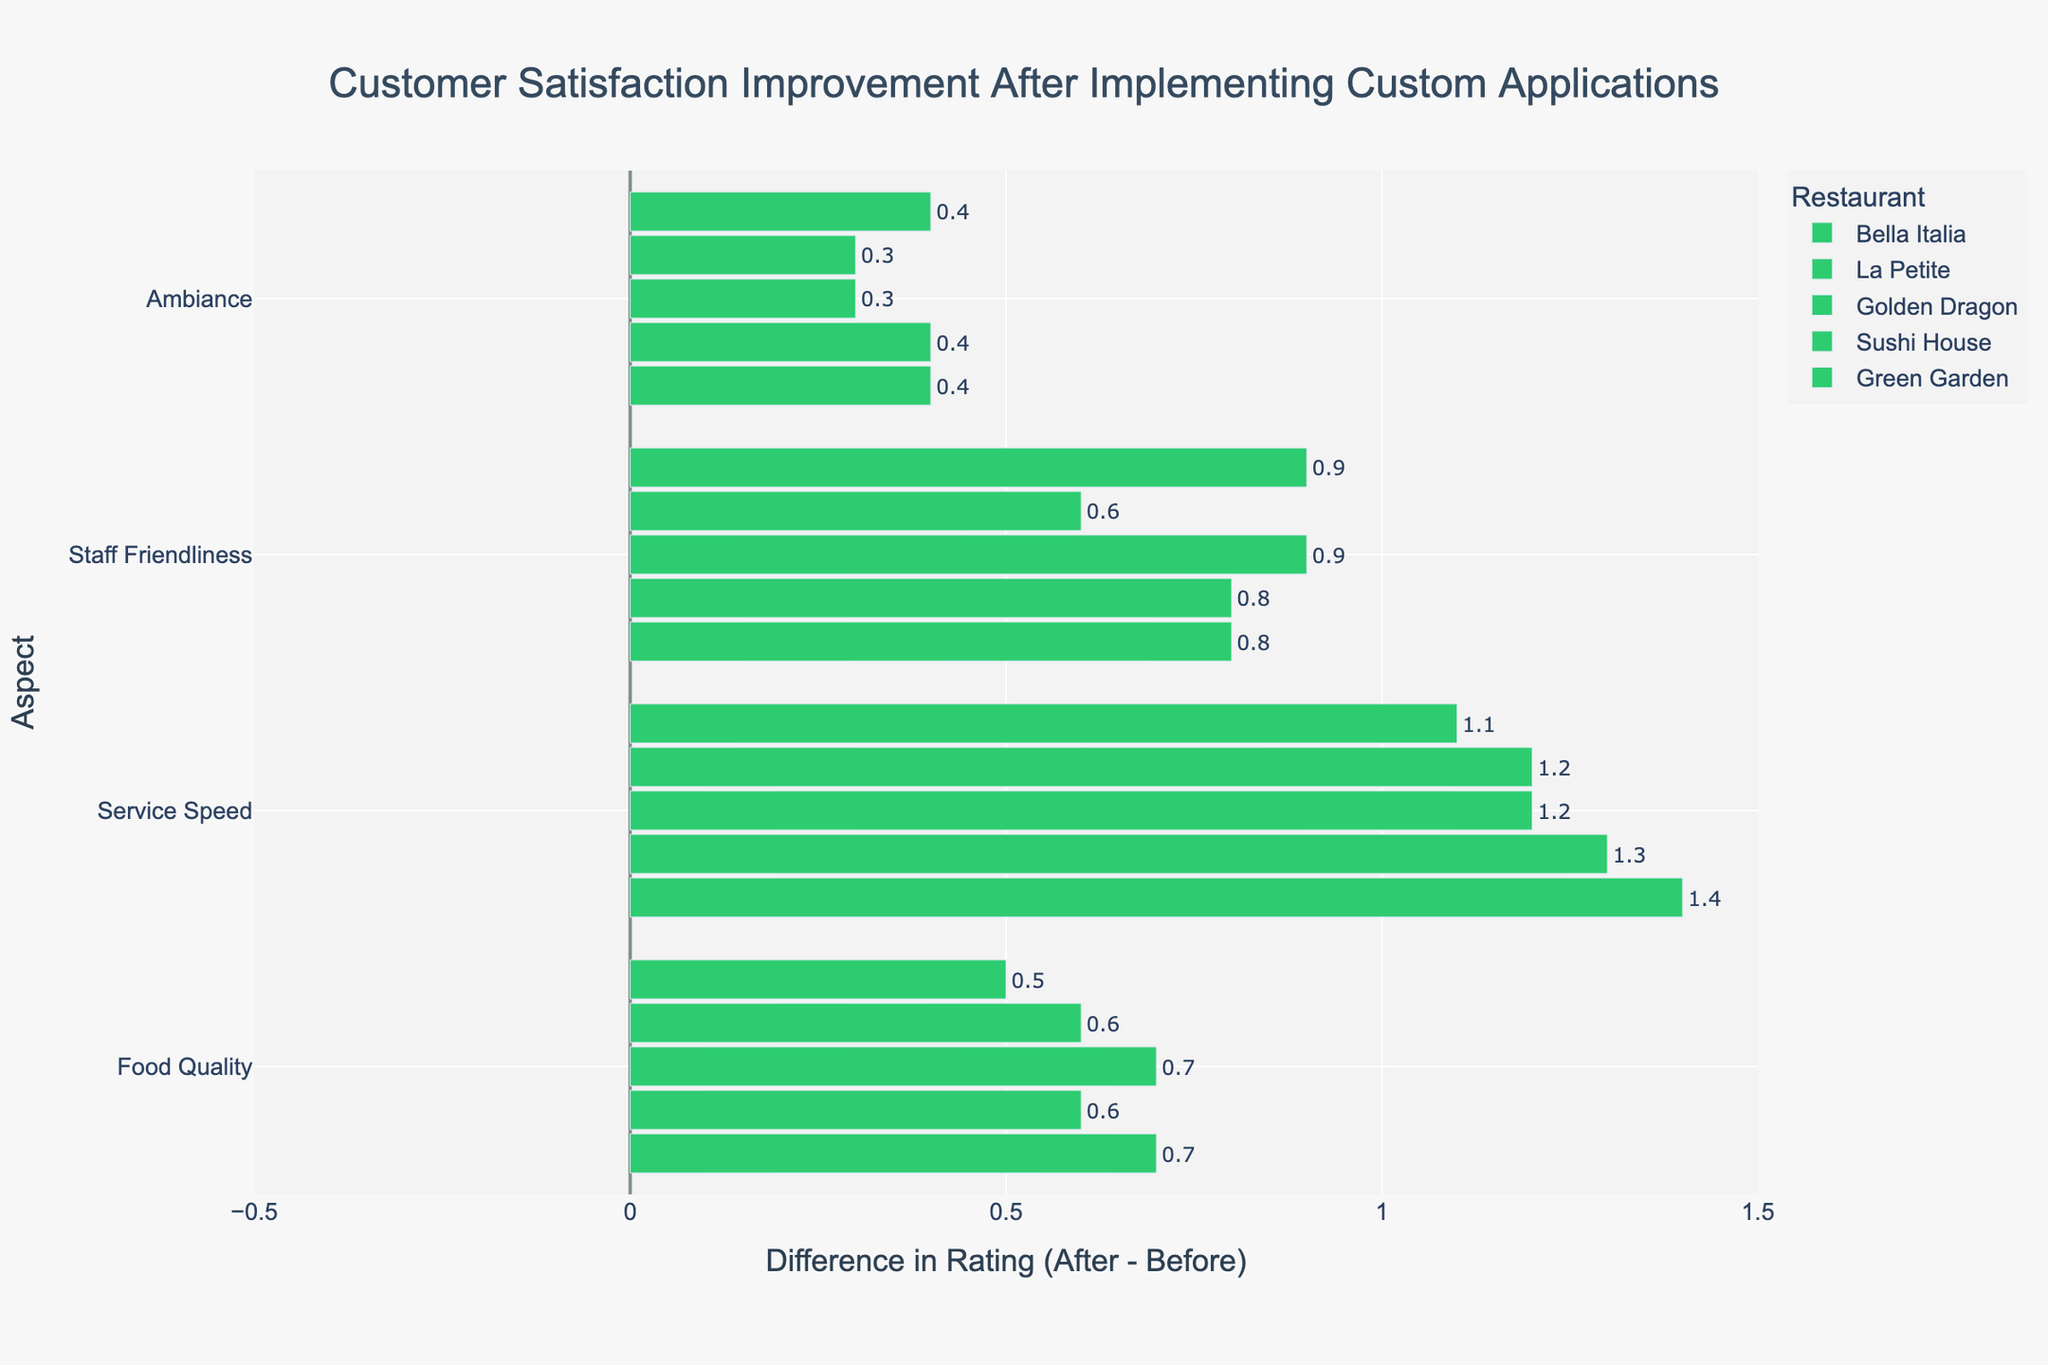What's the difference in average customer satisfaction in Food Quality for all restaurants after implementation? To calculate the average difference in Food Quality ratings after implementation, sum up the differences for all restaurants, then divide by the number of restaurants. The differences are Bella Italia (0.7), La Petite (0.6), Golden Dragon (0.7), Sushi House (0.6), and Green Garden (0.5). So, (0.7 + 0.6 + 0.7 + 0.6 + 0.5) / 5 = 3.1 / 5 = 0.62.
Answer: 0.62 Which restaurant showed the greatest improvement in Service Speed? The improvement in Service Speed for each restaurant is visible by comparing the length of the green bars. Bella Italia improved by 1.4, La Petite by 1.3, Golden Dragon by 1.2, Sushi House by 1.2, and Green Garden by 1.1. The longest green bar is for Bella Italia.
Answer: Bella Italia Which aspect had the least improvement in Bella Italia? Look at Bella Italia's bars and compare the lengths. Food Quality improved by 0.7, Service Speed by 1.4, Staff Friendliness by 0.8, Ambiance by 0.4. The Ambiance bar is the shortest.
Answer: Ambiance Are there any aspects where any restaurant had a negative improvement? Observe the color of the bars; green bars indicate positive improvement, and red would indicate negative. All bars are green, meaning no aspects had negative improvement.
Answer: No What's the total improvement in Staff Friendliness for all restaurants? Sum the improvements in Staff Friendliness for all restaurants: Bella Italia (0.8), La Petite (0.8), Golden Dragon (0.9), Sushi House (0.6), and Green Garden (0.9). So, 0.8 + 0.8 + 0.9 + 0.6 + 0.9 = 4.0.
Answer: 4.0 